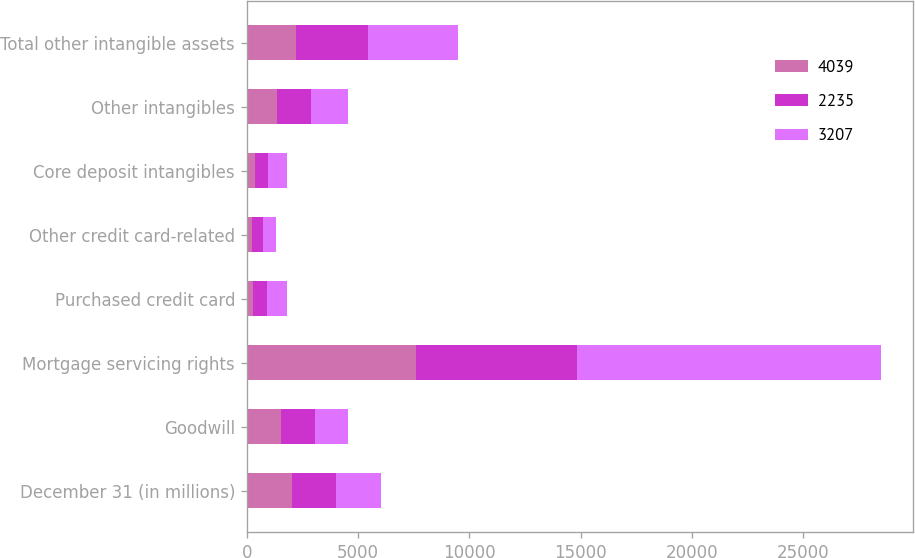<chart> <loc_0><loc_0><loc_500><loc_500><stacked_bar_chart><ecel><fcel>December 31 (in millions)<fcel>Goodwill<fcel>Mortgage servicing rights<fcel>Purchased credit card<fcel>Other credit card-related<fcel>Core deposit intangibles<fcel>Other intangibles<fcel>Total other intangible assets<nl><fcel>4039<fcel>2012<fcel>1523<fcel>7614<fcel>295<fcel>229<fcel>355<fcel>1356<fcel>2235<nl><fcel>2235<fcel>2011<fcel>1523<fcel>7223<fcel>602<fcel>488<fcel>594<fcel>1523<fcel>3207<nl><fcel>3207<fcel>2010<fcel>1523<fcel>13649<fcel>897<fcel>593<fcel>879<fcel>1670<fcel>4039<nl></chart> 